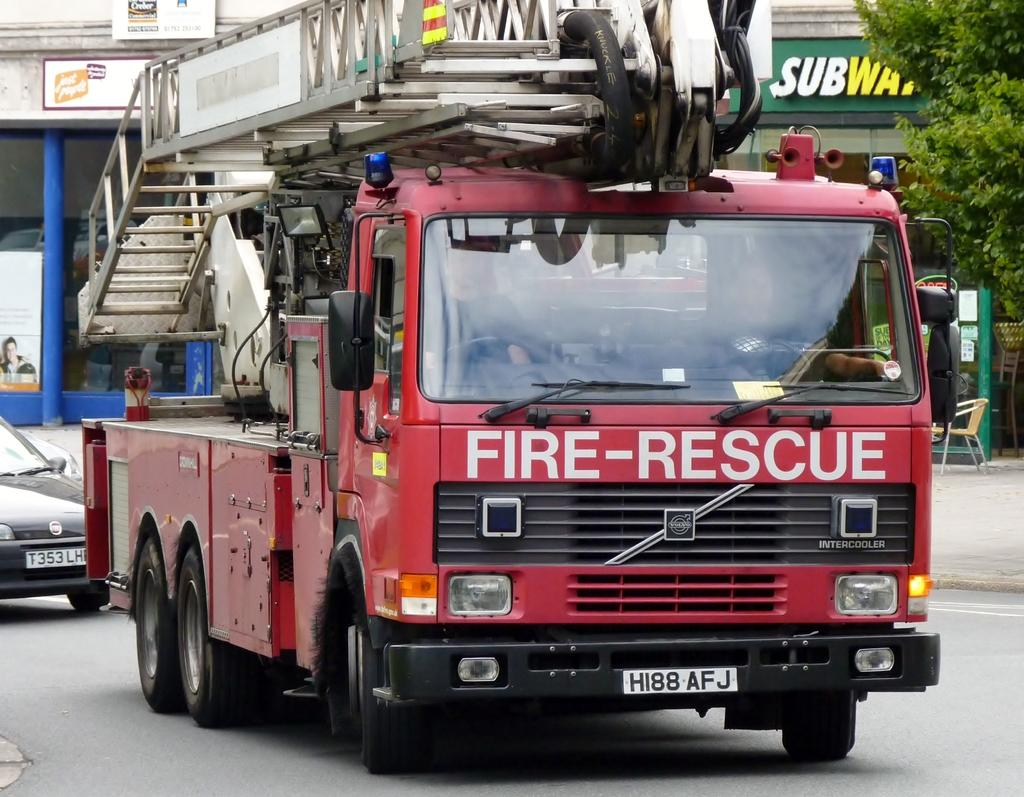What type of vehicle is in the image? There is a red color truck in the image. What else can be seen in the image besides the truck? There are buildings, stairs, a car, a chair, and a tree in the image. Can you describe the stairs in the image? Yes, there are stairs in the image. What is the color of the car in the image? The color of the car in the image is not mentioned in the facts. Is there any vegetation visible in the image? Yes, there is a tree in the image. What type of ornament is hanging from the top of the tree in the image? There is no mention of an ornament hanging from the top of the tree in the image. 